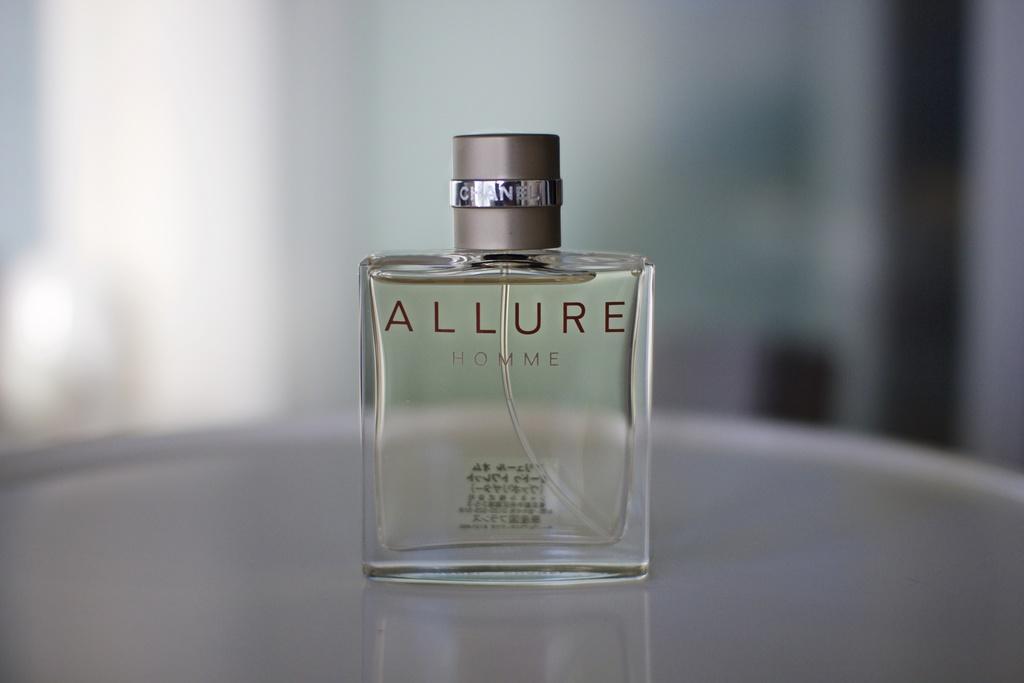What is the name of the perfume?
Your response must be concise. Allure. 